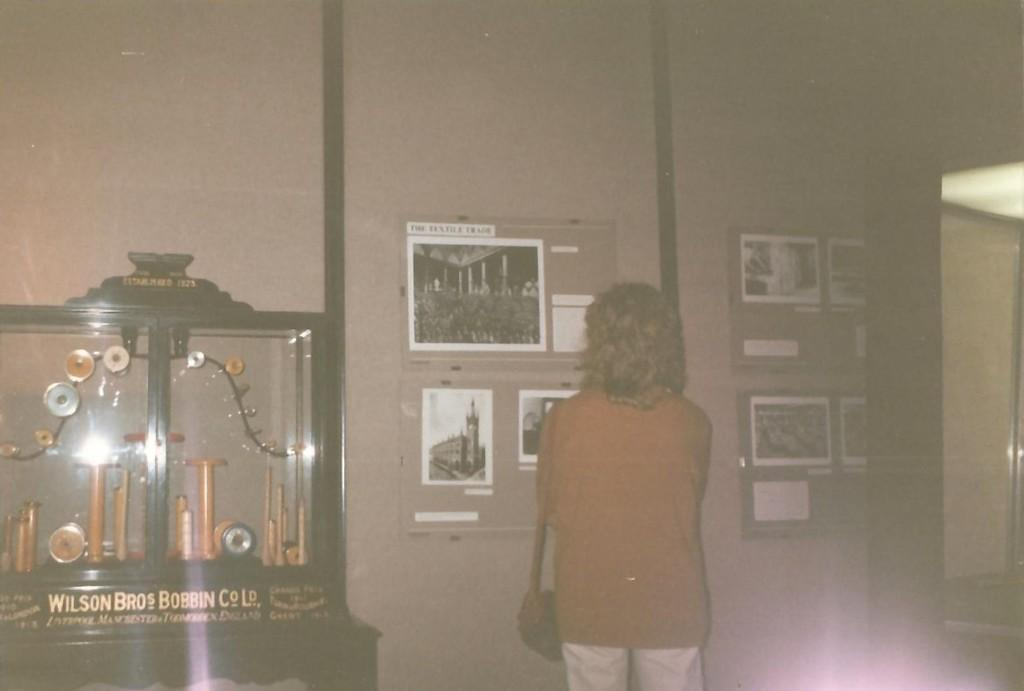What can be seen on the notice boards in the image? There are posters on the notice boards in the image. Can you describe the person in the image? There is a person standing in the image. What type of equipment is present in the image? There is an equipment with clock timers and other objects in the image. What type of container is visible in the image? There is a glass in the image. What type of guide can be seen leading a group of people through the bushes in the image? There are no bushes or guides present in the image; it features notice boards with posters, a person standing, equipment with clock timers, and a glass. Is there a baseball game happening in the image? There is no baseball game or any reference to sports in the image. 